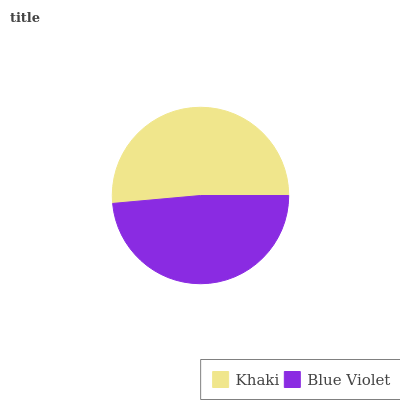Is Blue Violet the minimum?
Answer yes or no. Yes. Is Khaki the maximum?
Answer yes or no. Yes. Is Blue Violet the maximum?
Answer yes or no. No. Is Khaki greater than Blue Violet?
Answer yes or no. Yes. Is Blue Violet less than Khaki?
Answer yes or no. Yes. Is Blue Violet greater than Khaki?
Answer yes or no. No. Is Khaki less than Blue Violet?
Answer yes or no. No. Is Khaki the high median?
Answer yes or no. Yes. Is Blue Violet the low median?
Answer yes or no. Yes. Is Blue Violet the high median?
Answer yes or no. No. Is Khaki the low median?
Answer yes or no. No. 